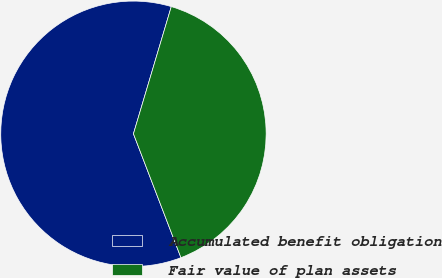<chart> <loc_0><loc_0><loc_500><loc_500><pie_chart><fcel>Accumulated benefit obligation<fcel>Fair value of plan assets<nl><fcel>60.43%<fcel>39.57%<nl></chart> 